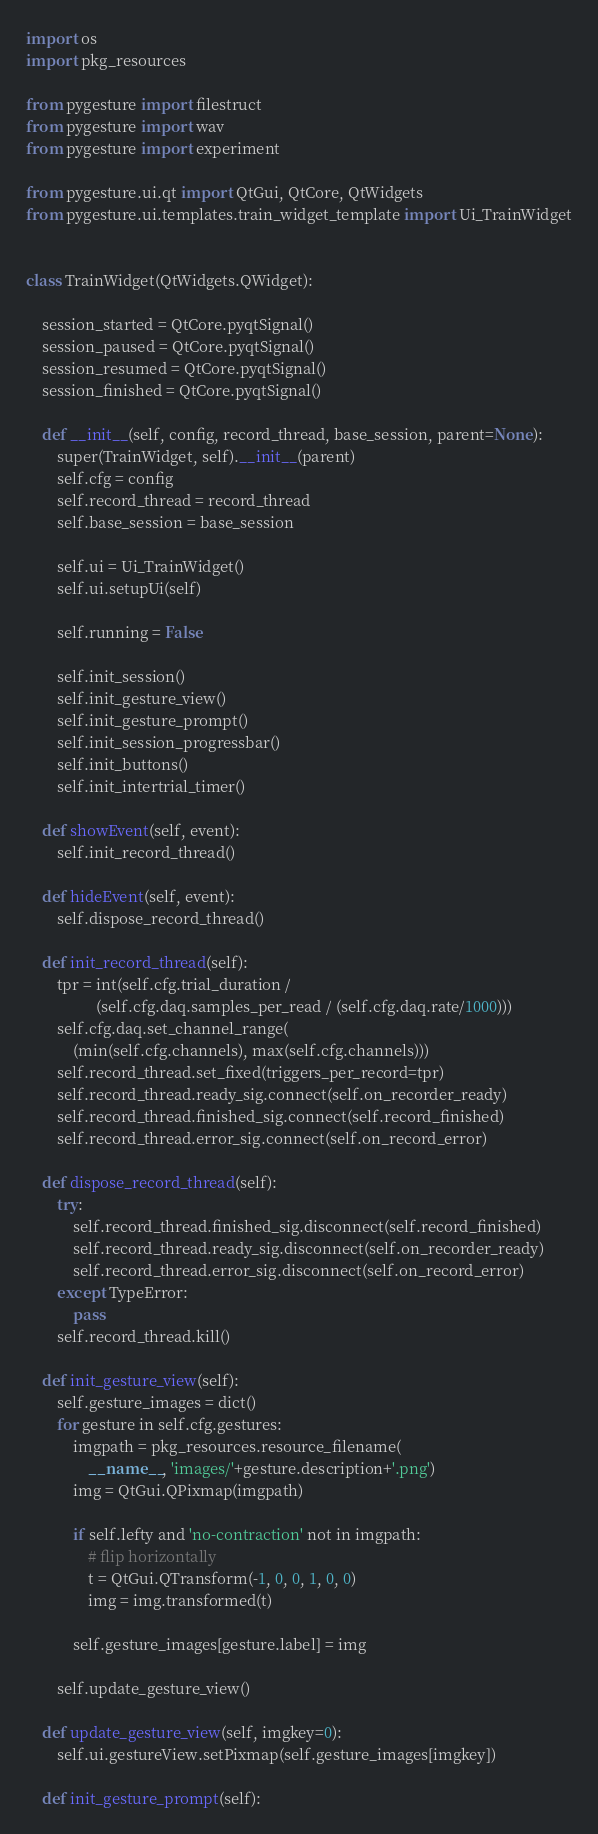<code> <loc_0><loc_0><loc_500><loc_500><_Python_>import os
import pkg_resources

from pygesture import filestruct
from pygesture import wav
from pygesture import experiment

from pygesture.ui.qt import QtGui, QtCore, QtWidgets
from pygesture.ui.templates.train_widget_template import Ui_TrainWidget


class TrainWidget(QtWidgets.QWidget):

    session_started = QtCore.pyqtSignal()
    session_paused = QtCore.pyqtSignal()
    session_resumed = QtCore.pyqtSignal()
    session_finished = QtCore.pyqtSignal()

    def __init__(self, config, record_thread, base_session, parent=None):
        super(TrainWidget, self).__init__(parent)
        self.cfg = config
        self.record_thread = record_thread
        self.base_session = base_session

        self.ui = Ui_TrainWidget()
        self.ui.setupUi(self)

        self.running = False

        self.init_session()
        self.init_gesture_view()
        self.init_gesture_prompt()
        self.init_session_progressbar()
        self.init_buttons()
        self.init_intertrial_timer()

    def showEvent(self, event):
        self.init_record_thread()

    def hideEvent(self, event):
        self.dispose_record_thread()

    def init_record_thread(self):
        tpr = int(self.cfg.trial_duration /
                  (self.cfg.daq.samples_per_read / (self.cfg.daq.rate/1000)))
        self.cfg.daq.set_channel_range(
            (min(self.cfg.channels), max(self.cfg.channels)))
        self.record_thread.set_fixed(triggers_per_record=tpr)
        self.record_thread.ready_sig.connect(self.on_recorder_ready)
        self.record_thread.finished_sig.connect(self.record_finished)
        self.record_thread.error_sig.connect(self.on_record_error)

    def dispose_record_thread(self):
        try:
            self.record_thread.finished_sig.disconnect(self.record_finished)
            self.record_thread.ready_sig.disconnect(self.on_recorder_ready)
            self.record_thread.error_sig.disconnect(self.on_record_error)
        except TypeError:
            pass
        self.record_thread.kill()

    def init_gesture_view(self):
        self.gesture_images = dict()
        for gesture in self.cfg.gestures:
            imgpath = pkg_resources.resource_filename(
                __name__, 'images/'+gesture.description+'.png')
            img = QtGui.QPixmap(imgpath)

            if self.lefty and 'no-contraction' not in imgpath:
                # flip horizontally
                t = QtGui.QTransform(-1, 0, 0, 1, 0, 0)
                img = img.transformed(t)

            self.gesture_images[gesture.label] = img

        self.update_gesture_view()

    def update_gesture_view(self, imgkey=0):
        self.ui.gestureView.setPixmap(self.gesture_images[imgkey])

    def init_gesture_prompt(self):</code> 